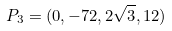Convert formula to latex. <formula><loc_0><loc_0><loc_500><loc_500>P _ { 3 } = ( 0 , - 7 2 , 2 \sqrt { 3 } , 1 2 )</formula> 